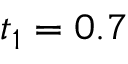Convert formula to latex. <formula><loc_0><loc_0><loc_500><loc_500>t _ { 1 } = 0 . 7</formula> 